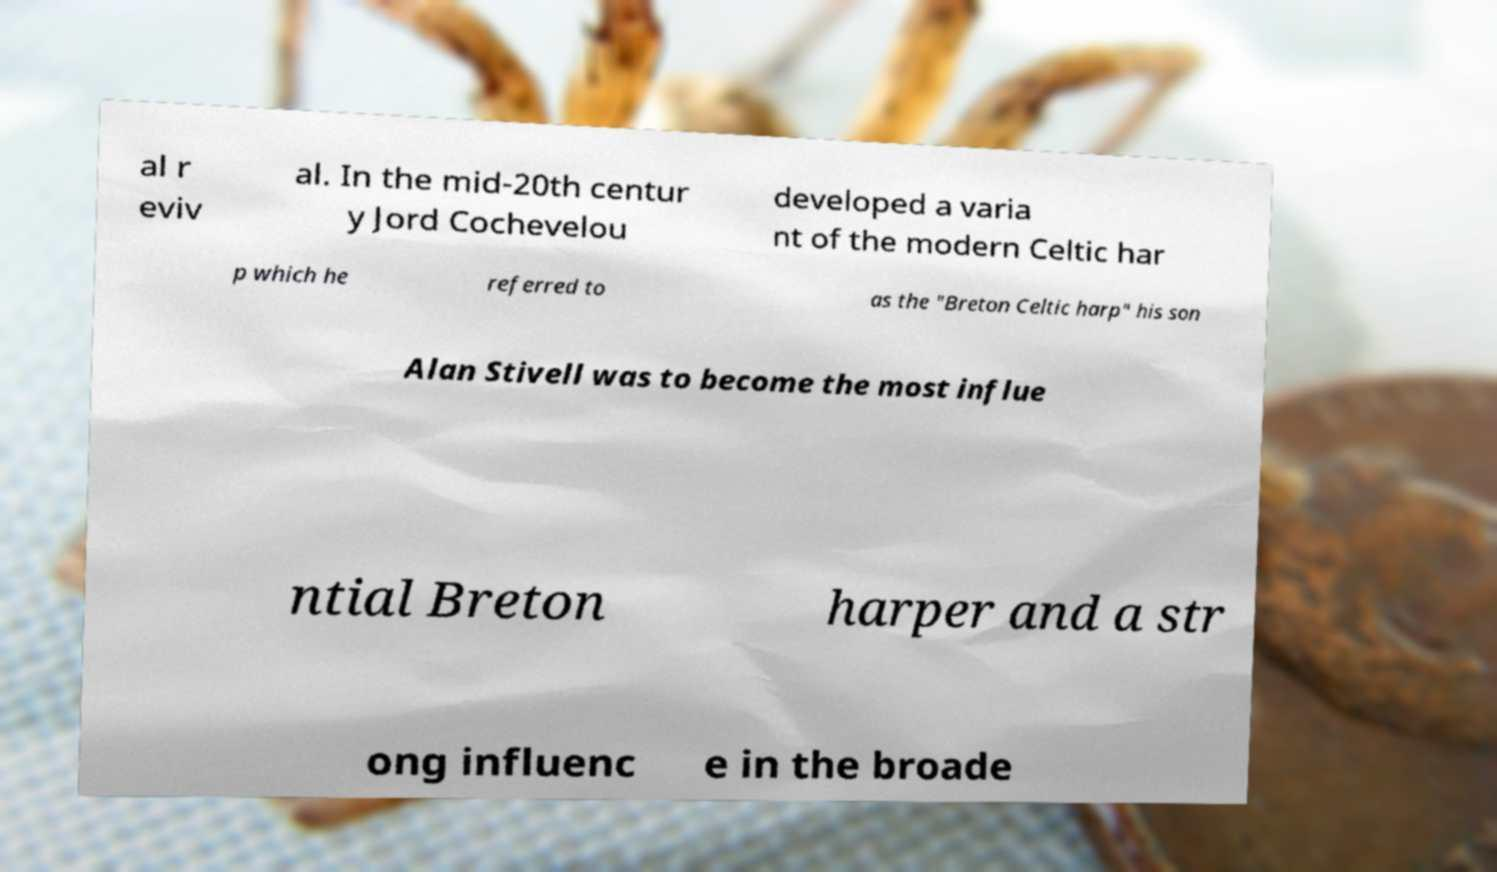For documentation purposes, I need the text within this image transcribed. Could you provide that? al r eviv al. In the mid-20th centur y Jord Cochevelou developed a varia nt of the modern Celtic har p which he referred to as the "Breton Celtic harp" his son Alan Stivell was to become the most influe ntial Breton harper and a str ong influenc e in the broade 